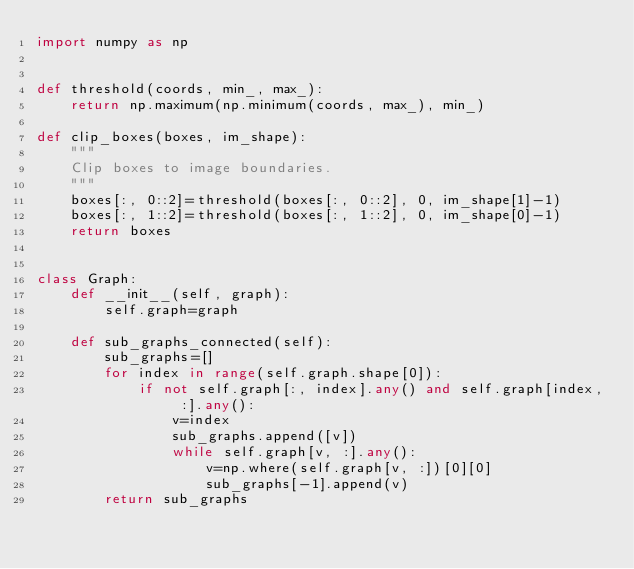<code> <loc_0><loc_0><loc_500><loc_500><_Python_>import numpy as np


def threshold(coords, min_, max_):
    return np.maximum(np.minimum(coords, max_), min_)

def clip_boxes(boxes, im_shape):
    """
    Clip boxes to image boundaries.
    """
    boxes[:, 0::2]=threshold(boxes[:, 0::2], 0, im_shape[1]-1)
    boxes[:, 1::2]=threshold(boxes[:, 1::2], 0, im_shape[0]-1)
    return boxes


class Graph:
    def __init__(self, graph):
        self.graph=graph

    def sub_graphs_connected(self):
        sub_graphs=[]
        for index in range(self.graph.shape[0]):
            if not self.graph[:, index].any() and self.graph[index, :].any():
                v=index
                sub_graphs.append([v])
                while self.graph[v, :].any():
                    v=np.where(self.graph[v, :])[0][0]
                    sub_graphs[-1].append(v)
        return sub_graphs

</code> 